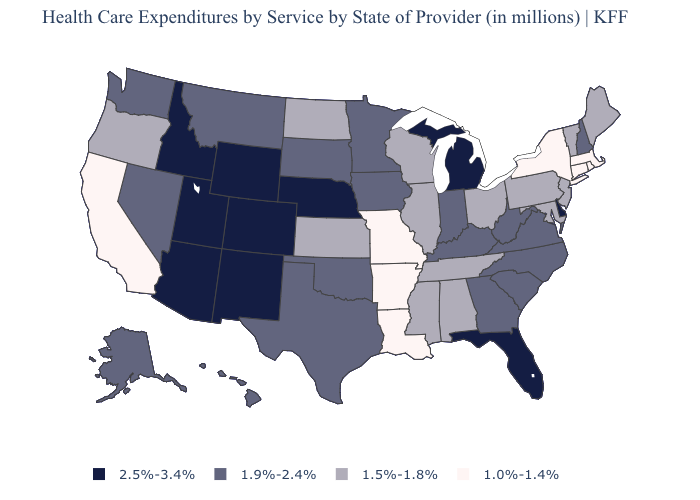Does Kansas have a lower value than Colorado?
Short answer required. Yes. Among the states that border Michigan , does Wisconsin have the highest value?
Write a very short answer. No. Name the states that have a value in the range 1.0%-1.4%?
Keep it brief. Arkansas, California, Connecticut, Louisiana, Massachusetts, Missouri, New York, Rhode Island. What is the highest value in states that border Utah?
Answer briefly. 2.5%-3.4%. Among the states that border Louisiana , which have the highest value?
Short answer required. Texas. Is the legend a continuous bar?
Be succinct. No. Is the legend a continuous bar?
Answer briefly. No. What is the highest value in states that border Idaho?
Write a very short answer. 2.5%-3.4%. What is the highest value in the USA?
Short answer required. 2.5%-3.4%. What is the value of Connecticut?
Answer briefly. 1.0%-1.4%. Does Vermont have the lowest value in the Northeast?
Answer briefly. No. What is the value of Kansas?
Be succinct. 1.5%-1.8%. What is the value of South Carolina?
Write a very short answer. 1.9%-2.4%. What is the lowest value in states that border Florida?
Concise answer only. 1.5%-1.8%. What is the value of Virginia?
Give a very brief answer. 1.9%-2.4%. 